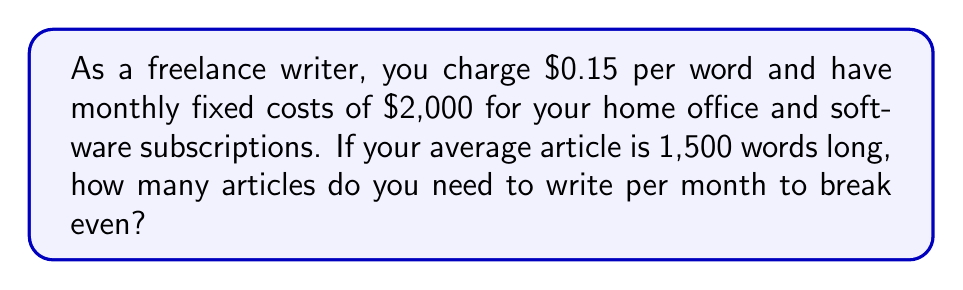Solve this math problem. Let's approach this step-by-step using a linear equation:

1) Define variables:
   Let $x$ = number of articles written per month

2) Calculate revenue per article:
   Revenue per article = $0.15 \times 1,500 = $225$

3) Set up the break-even equation:
   At the break-even point, total revenue equals total costs
   $$225x = 2000 + 0x$$

   Here, $225x$ represents the total revenue, and $2000$ represents the fixed costs. There are no variable costs in this scenario.

4) Solve the equation:
   $$225x = 2000$$
   $$x = \frac{2000}{225} \approx 8.89$$

5) Since we can't write a fraction of an article, we round up to the nearest whole number.
Answer: 9 articles 